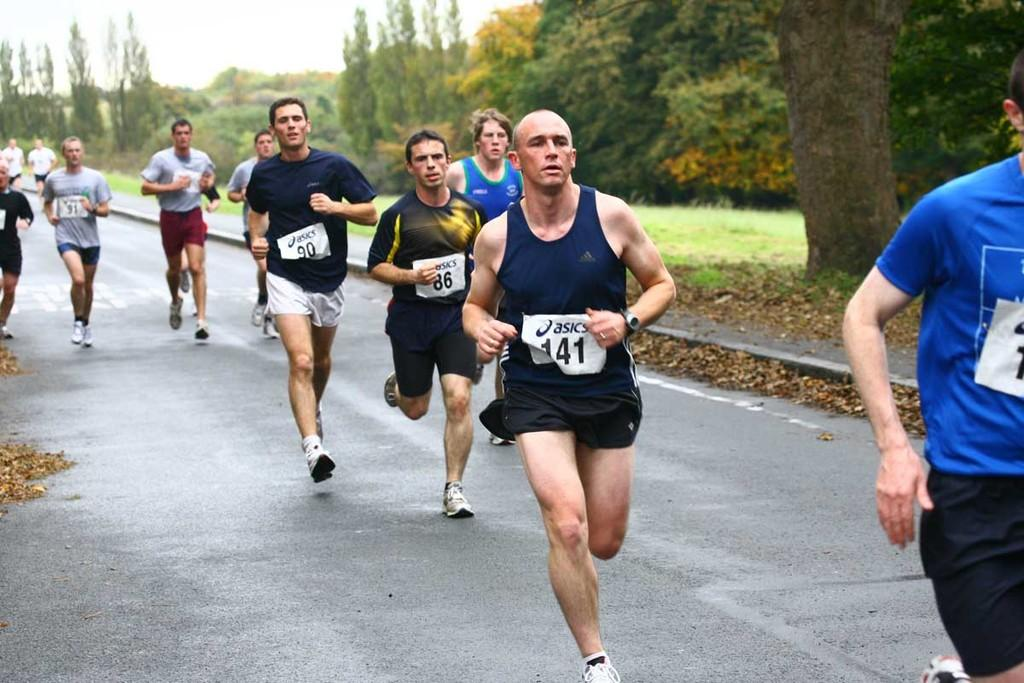Who or what can be seen in the image? There are people in the image. What are the people doing? The people are running. What is the setting of the image? The road is visible in the image. What can be seen in the background of the image? There are trees and grass in the background of the image. What is the chance of winning the lottery in the image? There is no mention of a lottery or any chance of winning in the image. 